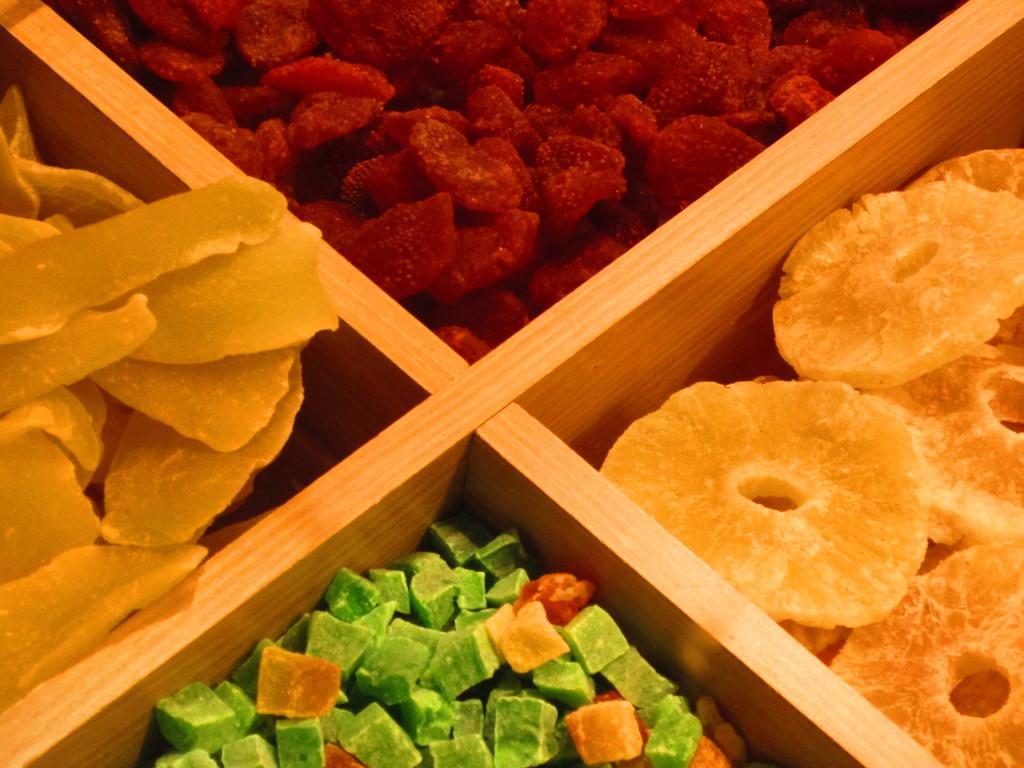In one or two sentences, can you explain what this image depicts? In this image we can see dry fruits arranged in shelves. 